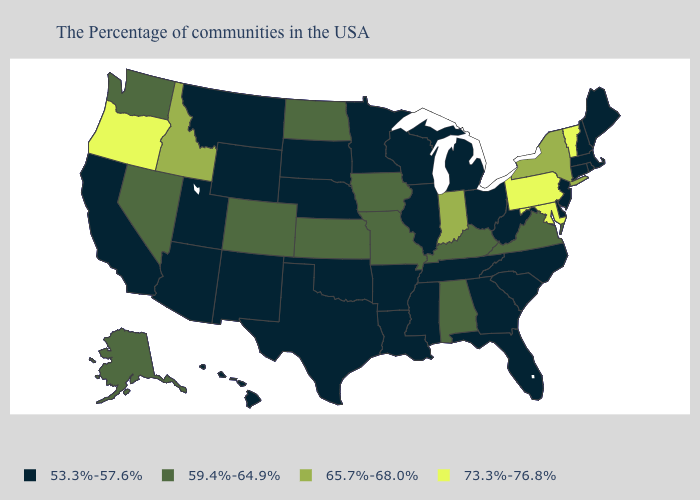What is the highest value in the USA?
Keep it brief. 73.3%-76.8%. Does Florida have a lower value than New Hampshire?
Concise answer only. No. Among the states that border Delaware , does Maryland have the lowest value?
Give a very brief answer. No. Which states hav the highest value in the Northeast?
Short answer required. Vermont, Pennsylvania. Name the states that have a value in the range 59.4%-64.9%?
Keep it brief. Virginia, Kentucky, Alabama, Missouri, Iowa, Kansas, North Dakota, Colorado, Nevada, Washington, Alaska. Does North Dakota have the lowest value in the USA?
Concise answer only. No. What is the value of North Carolina?
Keep it brief. 53.3%-57.6%. Name the states that have a value in the range 65.7%-68.0%?
Give a very brief answer. New York, Indiana, Idaho. Name the states that have a value in the range 59.4%-64.9%?
Keep it brief. Virginia, Kentucky, Alabama, Missouri, Iowa, Kansas, North Dakota, Colorado, Nevada, Washington, Alaska. Name the states that have a value in the range 65.7%-68.0%?
Quick response, please. New York, Indiana, Idaho. Name the states that have a value in the range 73.3%-76.8%?
Answer briefly. Vermont, Maryland, Pennsylvania, Oregon. Does Vermont have the highest value in the USA?
Concise answer only. Yes. Does New Hampshire have the lowest value in the Northeast?
Answer briefly. Yes. Name the states that have a value in the range 53.3%-57.6%?
Give a very brief answer. Maine, Massachusetts, Rhode Island, New Hampshire, Connecticut, New Jersey, Delaware, North Carolina, South Carolina, West Virginia, Ohio, Florida, Georgia, Michigan, Tennessee, Wisconsin, Illinois, Mississippi, Louisiana, Arkansas, Minnesota, Nebraska, Oklahoma, Texas, South Dakota, Wyoming, New Mexico, Utah, Montana, Arizona, California, Hawaii. Name the states that have a value in the range 59.4%-64.9%?
Give a very brief answer. Virginia, Kentucky, Alabama, Missouri, Iowa, Kansas, North Dakota, Colorado, Nevada, Washington, Alaska. 